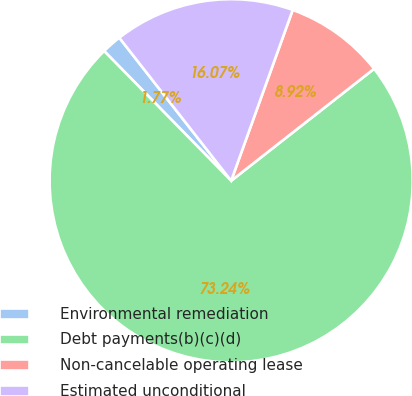<chart> <loc_0><loc_0><loc_500><loc_500><pie_chart><fcel>Environmental remediation<fcel>Debt payments(b)(c)(d)<fcel>Non-cancelable operating lease<fcel>Estimated unconditional<nl><fcel>1.77%<fcel>73.25%<fcel>8.92%<fcel>16.07%<nl></chart> 